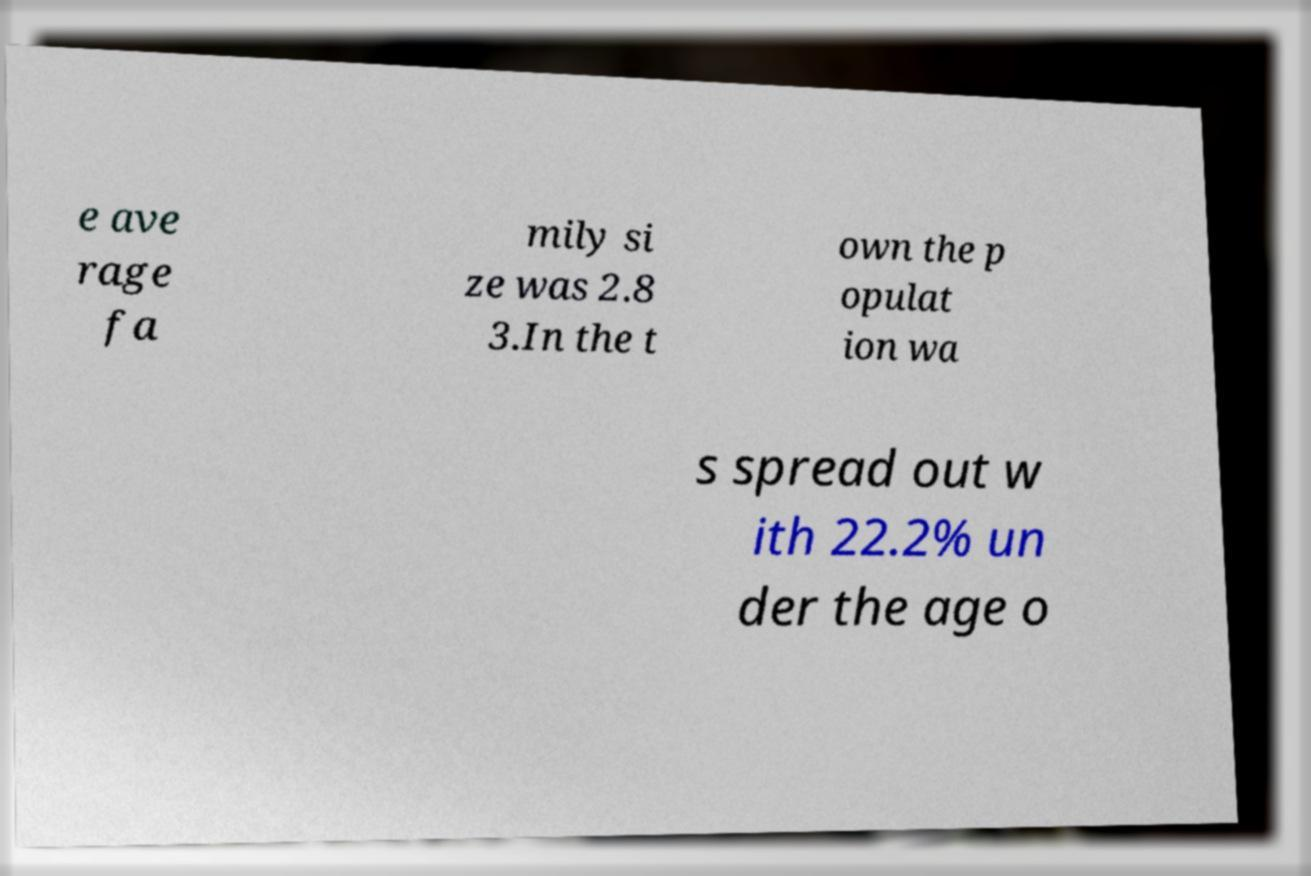For documentation purposes, I need the text within this image transcribed. Could you provide that? e ave rage fa mily si ze was 2.8 3.In the t own the p opulat ion wa s spread out w ith 22.2% un der the age o 